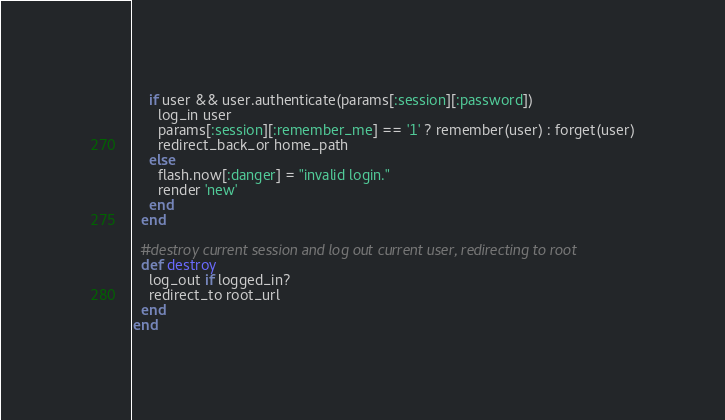Convert code to text. <code><loc_0><loc_0><loc_500><loc_500><_Ruby_>    if user && user.authenticate(params[:session][:password])
      log_in user
      params[:session][:remember_me] == '1' ? remember(user) : forget(user)
      redirect_back_or home_path
    else
      flash.now[:danger] = "invalid login."
      render 'new'
    end
  end

  #destroy current session and log out current user, redirecting to root
  def destroy
    log_out if logged_in?
    redirect_to root_url
  end
end
</code> 